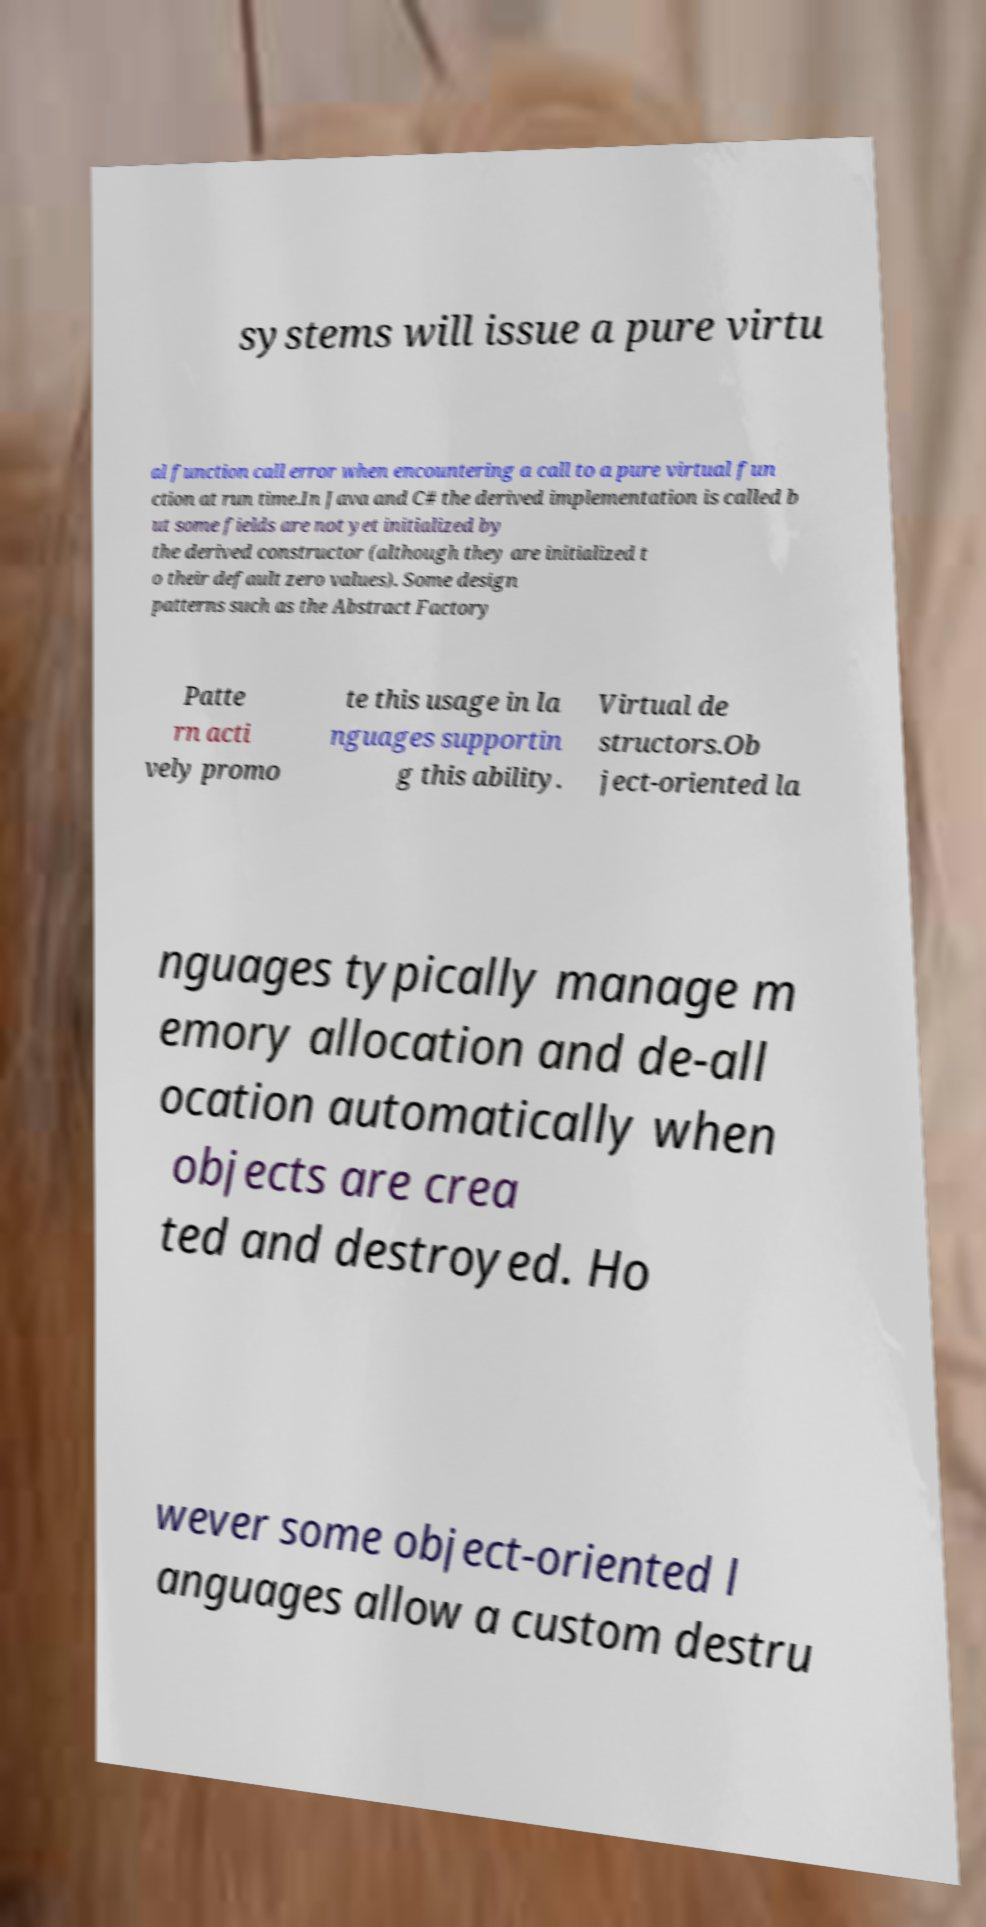There's text embedded in this image that I need extracted. Can you transcribe it verbatim? systems will issue a pure virtu al function call error when encountering a call to a pure virtual fun ction at run time.In Java and C# the derived implementation is called b ut some fields are not yet initialized by the derived constructor (although they are initialized t o their default zero values). Some design patterns such as the Abstract Factory Patte rn acti vely promo te this usage in la nguages supportin g this ability. Virtual de structors.Ob ject-oriented la nguages typically manage m emory allocation and de-all ocation automatically when objects are crea ted and destroyed. Ho wever some object-oriented l anguages allow a custom destru 